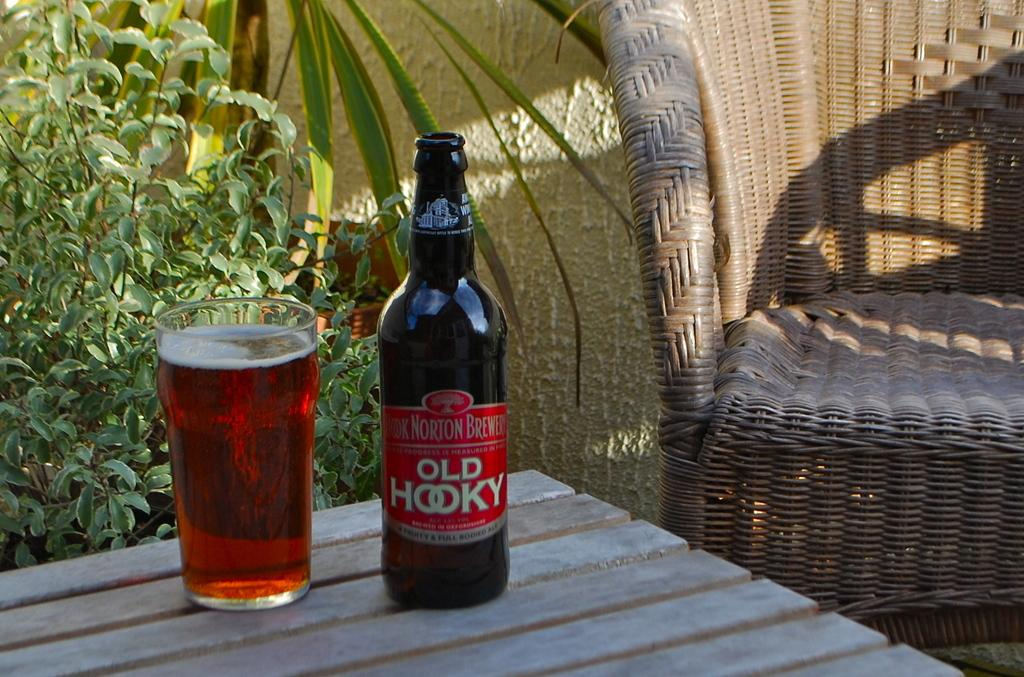Provide a one-sentence caption for the provided image. A bottle of Old Hooky sits on the table next to a filled glass of the drink. 